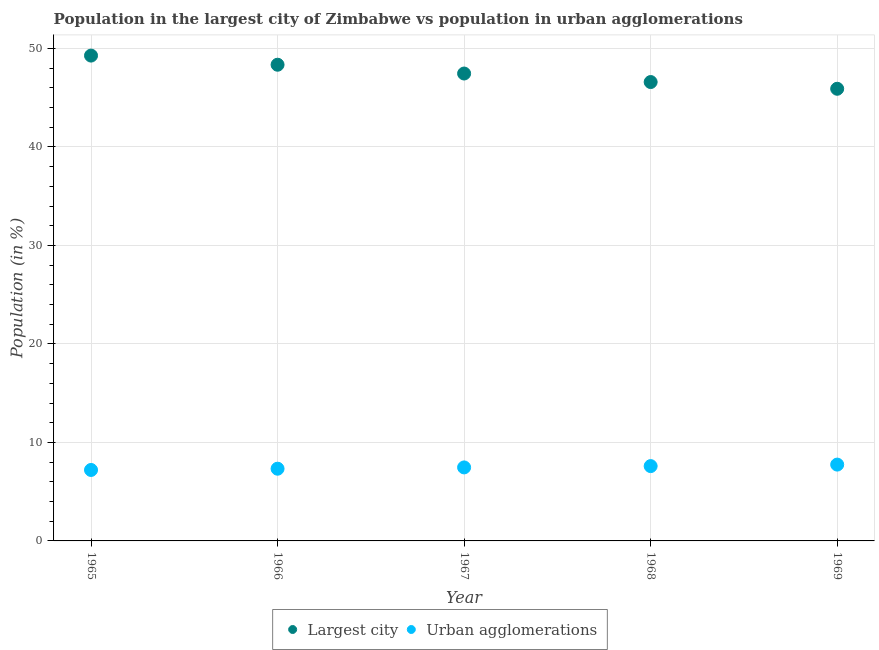What is the population in the largest city in 1965?
Provide a succinct answer. 49.28. Across all years, what is the maximum population in the largest city?
Your response must be concise. 49.28. Across all years, what is the minimum population in urban agglomerations?
Your response must be concise. 7.2. In which year was the population in urban agglomerations maximum?
Provide a succinct answer. 1969. In which year was the population in the largest city minimum?
Your answer should be compact. 1969. What is the total population in the largest city in the graph?
Your answer should be very brief. 237.58. What is the difference between the population in urban agglomerations in 1967 and that in 1968?
Ensure brevity in your answer.  -0.13. What is the difference between the population in the largest city in 1966 and the population in urban agglomerations in 1969?
Give a very brief answer. 40.6. What is the average population in the largest city per year?
Give a very brief answer. 47.52. In the year 1966, what is the difference between the population in the largest city and population in urban agglomerations?
Offer a terse response. 41.02. In how many years, is the population in the largest city greater than 8 %?
Provide a short and direct response. 5. What is the ratio of the population in the largest city in 1966 to that in 1969?
Make the answer very short. 1.05. What is the difference between the highest and the second highest population in urban agglomerations?
Offer a very short reply. 0.15. What is the difference between the highest and the lowest population in urban agglomerations?
Your answer should be compact. 0.55. In how many years, is the population in urban agglomerations greater than the average population in urban agglomerations taken over all years?
Give a very brief answer. 2. Is the population in the largest city strictly greater than the population in urban agglomerations over the years?
Offer a very short reply. Yes. Does the graph contain any zero values?
Your answer should be compact. No. Where does the legend appear in the graph?
Provide a short and direct response. Bottom center. How many legend labels are there?
Provide a short and direct response. 2. What is the title of the graph?
Your answer should be compact. Population in the largest city of Zimbabwe vs population in urban agglomerations. Does "Central government" appear as one of the legend labels in the graph?
Provide a succinct answer. No. What is the label or title of the X-axis?
Offer a terse response. Year. What is the label or title of the Y-axis?
Your answer should be very brief. Population (in %). What is the Population (in %) in Largest city in 1965?
Provide a succinct answer. 49.28. What is the Population (in %) in Urban agglomerations in 1965?
Offer a terse response. 7.2. What is the Population (in %) of Largest city in 1966?
Give a very brief answer. 48.35. What is the Population (in %) in Urban agglomerations in 1966?
Offer a very short reply. 7.33. What is the Population (in %) in Largest city in 1967?
Keep it short and to the point. 47.46. What is the Population (in %) in Urban agglomerations in 1967?
Keep it short and to the point. 7.46. What is the Population (in %) of Largest city in 1968?
Give a very brief answer. 46.59. What is the Population (in %) of Urban agglomerations in 1968?
Your response must be concise. 7.6. What is the Population (in %) of Largest city in 1969?
Your response must be concise. 45.91. What is the Population (in %) of Urban agglomerations in 1969?
Offer a terse response. 7.75. Across all years, what is the maximum Population (in %) in Largest city?
Give a very brief answer. 49.28. Across all years, what is the maximum Population (in %) of Urban agglomerations?
Keep it short and to the point. 7.75. Across all years, what is the minimum Population (in %) in Largest city?
Your answer should be compact. 45.91. Across all years, what is the minimum Population (in %) of Urban agglomerations?
Offer a terse response. 7.2. What is the total Population (in %) in Largest city in the graph?
Make the answer very short. 237.58. What is the total Population (in %) of Urban agglomerations in the graph?
Make the answer very short. 37.35. What is the difference between the Population (in %) of Largest city in 1965 and that in 1966?
Offer a very short reply. 0.93. What is the difference between the Population (in %) in Urban agglomerations in 1965 and that in 1966?
Make the answer very short. -0.13. What is the difference between the Population (in %) of Largest city in 1965 and that in 1967?
Provide a succinct answer. 1.82. What is the difference between the Population (in %) of Urban agglomerations in 1965 and that in 1967?
Your answer should be compact. -0.26. What is the difference between the Population (in %) in Largest city in 1965 and that in 1968?
Offer a very short reply. 2.69. What is the difference between the Population (in %) of Urban agglomerations in 1965 and that in 1968?
Your answer should be compact. -0.39. What is the difference between the Population (in %) of Largest city in 1965 and that in 1969?
Offer a very short reply. 3.37. What is the difference between the Population (in %) in Urban agglomerations in 1965 and that in 1969?
Your answer should be compact. -0.55. What is the difference between the Population (in %) in Largest city in 1966 and that in 1967?
Provide a short and direct response. 0.89. What is the difference between the Population (in %) in Urban agglomerations in 1966 and that in 1967?
Your answer should be very brief. -0.13. What is the difference between the Population (in %) of Largest city in 1966 and that in 1968?
Make the answer very short. 1.76. What is the difference between the Population (in %) of Urban agglomerations in 1966 and that in 1968?
Your response must be concise. -0.27. What is the difference between the Population (in %) in Largest city in 1966 and that in 1969?
Your response must be concise. 2.44. What is the difference between the Population (in %) of Urban agglomerations in 1966 and that in 1969?
Provide a short and direct response. -0.42. What is the difference between the Population (in %) of Largest city in 1967 and that in 1968?
Your answer should be compact. 0.86. What is the difference between the Population (in %) in Urban agglomerations in 1967 and that in 1968?
Provide a succinct answer. -0.13. What is the difference between the Population (in %) in Largest city in 1967 and that in 1969?
Ensure brevity in your answer.  1.55. What is the difference between the Population (in %) in Urban agglomerations in 1967 and that in 1969?
Ensure brevity in your answer.  -0.29. What is the difference between the Population (in %) of Largest city in 1968 and that in 1969?
Your answer should be compact. 0.68. What is the difference between the Population (in %) in Urban agglomerations in 1968 and that in 1969?
Offer a terse response. -0.15. What is the difference between the Population (in %) in Largest city in 1965 and the Population (in %) in Urban agglomerations in 1966?
Offer a terse response. 41.94. What is the difference between the Population (in %) of Largest city in 1965 and the Population (in %) of Urban agglomerations in 1967?
Give a very brief answer. 41.81. What is the difference between the Population (in %) of Largest city in 1965 and the Population (in %) of Urban agglomerations in 1968?
Make the answer very short. 41.68. What is the difference between the Population (in %) in Largest city in 1965 and the Population (in %) in Urban agglomerations in 1969?
Your answer should be very brief. 41.53. What is the difference between the Population (in %) in Largest city in 1966 and the Population (in %) in Urban agglomerations in 1967?
Ensure brevity in your answer.  40.88. What is the difference between the Population (in %) in Largest city in 1966 and the Population (in %) in Urban agglomerations in 1968?
Offer a very short reply. 40.75. What is the difference between the Population (in %) in Largest city in 1966 and the Population (in %) in Urban agglomerations in 1969?
Offer a very short reply. 40.6. What is the difference between the Population (in %) of Largest city in 1967 and the Population (in %) of Urban agglomerations in 1968?
Provide a succinct answer. 39.86. What is the difference between the Population (in %) in Largest city in 1967 and the Population (in %) in Urban agglomerations in 1969?
Offer a terse response. 39.71. What is the difference between the Population (in %) in Largest city in 1968 and the Population (in %) in Urban agglomerations in 1969?
Give a very brief answer. 38.84. What is the average Population (in %) in Largest city per year?
Provide a succinct answer. 47.52. What is the average Population (in %) in Urban agglomerations per year?
Offer a very short reply. 7.47. In the year 1965, what is the difference between the Population (in %) of Largest city and Population (in %) of Urban agglomerations?
Keep it short and to the point. 42.07. In the year 1966, what is the difference between the Population (in %) in Largest city and Population (in %) in Urban agglomerations?
Keep it short and to the point. 41.02. In the year 1967, what is the difference between the Population (in %) in Largest city and Population (in %) in Urban agglomerations?
Make the answer very short. 39.99. In the year 1968, what is the difference between the Population (in %) of Largest city and Population (in %) of Urban agglomerations?
Your response must be concise. 38.99. In the year 1969, what is the difference between the Population (in %) in Largest city and Population (in %) in Urban agglomerations?
Your response must be concise. 38.16. What is the ratio of the Population (in %) of Largest city in 1965 to that in 1966?
Ensure brevity in your answer.  1.02. What is the ratio of the Population (in %) of Urban agglomerations in 1965 to that in 1966?
Ensure brevity in your answer.  0.98. What is the ratio of the Population (in %) of Largest city in 1965 to that in 1967?
Provide a succinct answer. 1.04. What is the ratio of the Population (in %) of Urban agglomerations in 1965 to that in 1967?
Provide a succinct answer. 0.97. What is the ratio of the Population (in %) in Largest city in 1965 to that in 1968?
Ensure brevity in your answer.  1.06. What is the ratio of the Population (in %) of Urban agglomerations in 1965 to that in 1968?
Give a very brief answer. 0.95. What is the ratio of the Population (in %) in Largest city in 1965 to that in 1969?
Ensure brevity in your answer.  1.07. What is the ratio of the Population (in %) of Urban agglomerations in 1965 to that in 1969?
Make the answer very short. 0.93. What is the ratio of the Population (in %) in Largest city in 1966 to that in 1967?
Your response must be concise. 1.02. What is the ratio of the Population (in %) in Urban agglomerations in 1966 to that in 1967?
Ensure brevity in your answer.  0.98. What is the ratio of the Population (in %) of Largest city in 1966 to that in 1968?
Offer a terse response. 1.04. What is the ratio of the Population (in %) of Urban agglomerations in 1966 to that in 1968?
Make the answer very short. 0.97. What is the ratio of the Population (in %) in Largest city in 1966 to that in 1969?
Offer a very short reply. 1.05. What is the ratio of the Population (in %) of Urban agglomerations in 1966 to that in 1969?
Give a very brief answer. 0.95. What is the ratio of the Population (in %) in Largest city in 1967 to that in 1968?
Keep it short and to the point. 1.02. What is the ratio of the Population (in %) of Urban agglomerations in 1967 to that in 1968?
Your answer should be compact. 0.98. What is the ratio of the Population (in %) of Largest city in 1967 to that in 1969?
Keep it short and to the point. 1.03. What is the ratio of the Population (in %) of Urban agglomerations in 1967 to that in 1969?
Give a very brief answer. 0.96. What is the ratio of the Population (in %) of Largest city in 1968 to that in 1969?
Your response must be concise. 1.01. What is the ratio of the Population (in %) of Urban agglomerations in 1968 to that in 1969?
Your answer should be very brief. 0.98. What is the difference between the highest and the second highest Population (in %) in Largest city?
Keep it short and to the point. 0.93. What is the difference between the highest and the second highest Population (in %) in Urban agglomerations?
Give a very brief answer. 0.15. What is the difference between the highest and the lowest Population (in %) in Largest city?
Give a very brief answer. 3.37. What is the difference between the highest and the lowest Population (in %) of Urban agglomerations?
Your response must be concise. 0.55. 